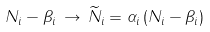<formula> <loc_0><loc_0><loc_500><loc_500>N _ { i } - \beta _ { i } \, \to \, \widetilde { N } _ { i } = \alpha _ { i } \left ( N _ { i } - \beta _ { i } \right )</formula> 